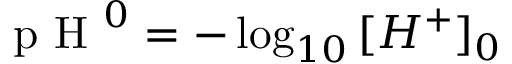<formula> <loc_0><loc_0><loc_500><loc_500>p H ^ { 0 } = - \log _ { 1 0 } { [ H ^ { + } ] _ { 0 } }</formula> 